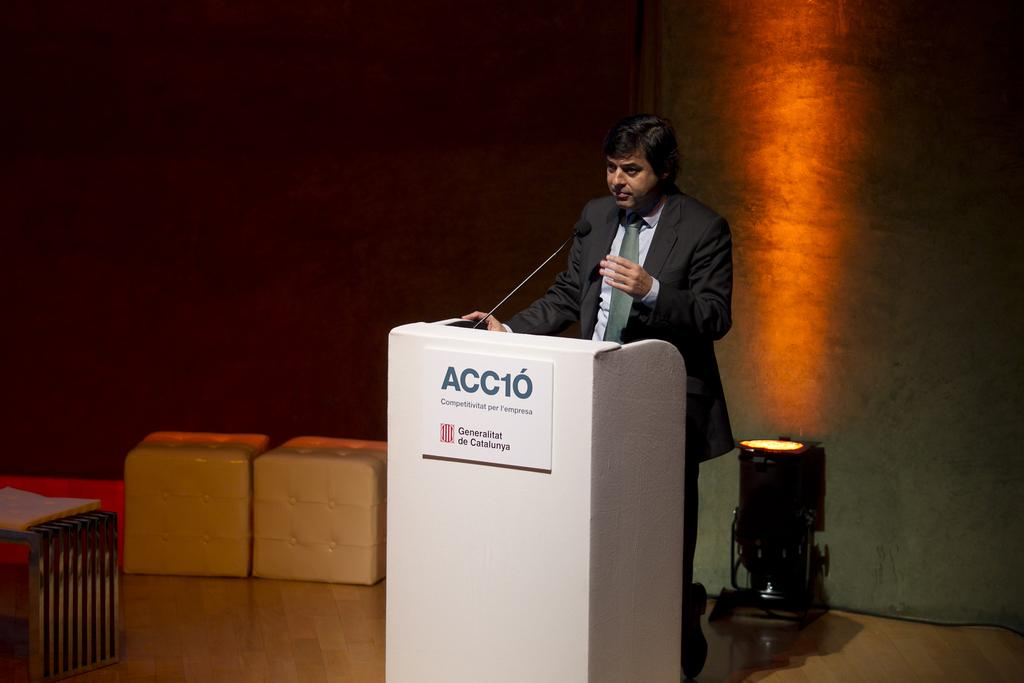What is the man in the image doing? The man is standing in the image. What is the man wearing? The man is wearing clothes and a tie. What is in front of the man? There is a podium in front of the man. What color is the podium? The podium is white in color. What is the man holding or using in the image? There is a microphone in the image. What type of structure can be seen in the background? There is a fence in the image. What is visible beneath the man's feet? There is a floor visible in the image. What can be seen providing illumination in the image? There is light in the image. What type of architectural feature is present in the background? There is a wall in the image. What type of volleyball game is being played in the image? There is no volleyball game present in the image. What type of home can be seen in the background of the image? There is no home visible in the image. 